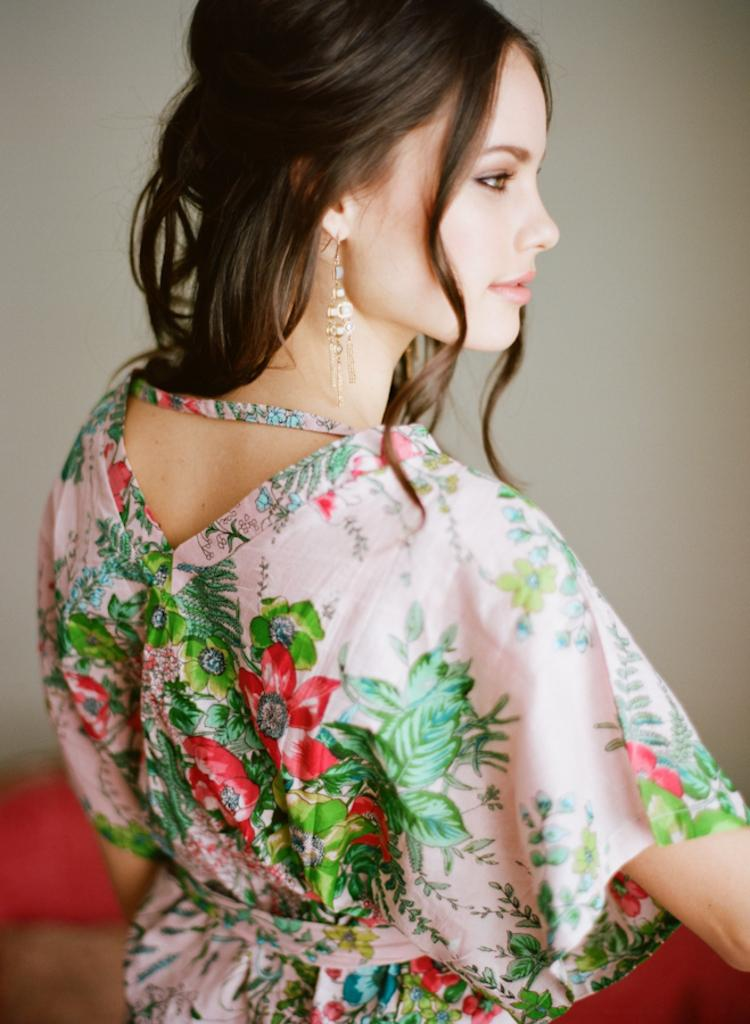Who is the main subject in the foreground of the image? There is a woman in the foreground of the image. What can be seen in the background of the image? There is a wall in the background of the image. What type of credit card does the woman have in her hand in the image? There is no credit card visible in the image; the woman's hands are not shown. What type of baseball bat is leaning against the wall in the image? There is no baseball bat present in the image; only the woman and the wall are visible. 